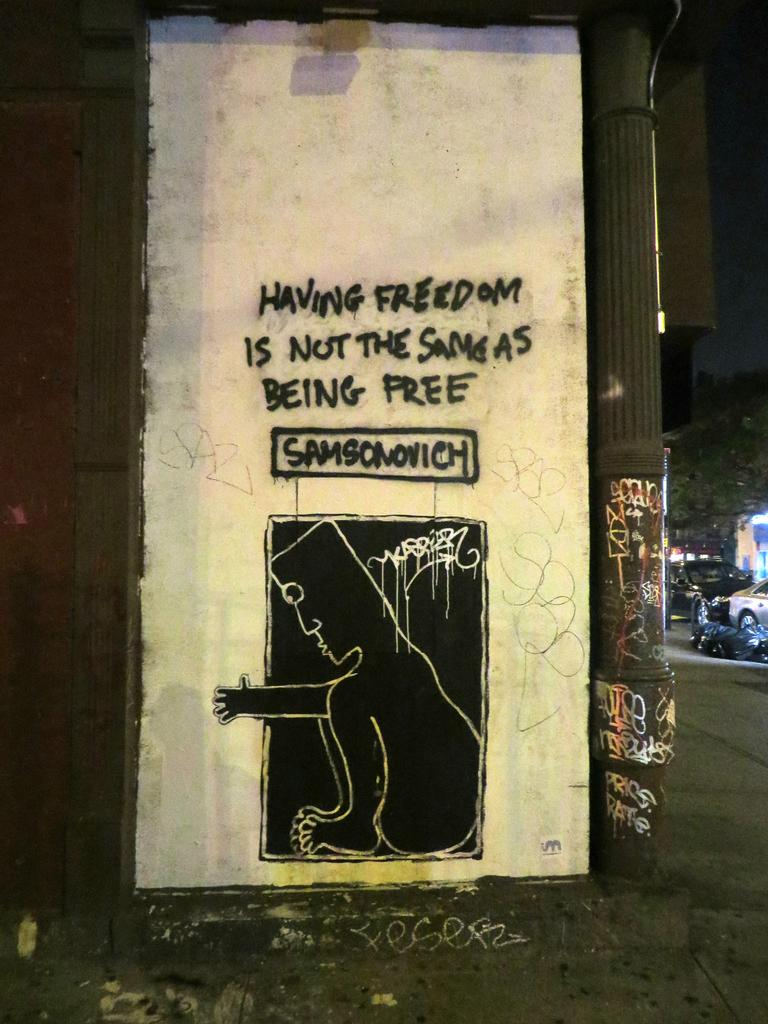<image>
Describe the image concisely. A wall of graffiti that reads having freedom is not the same as being free. 